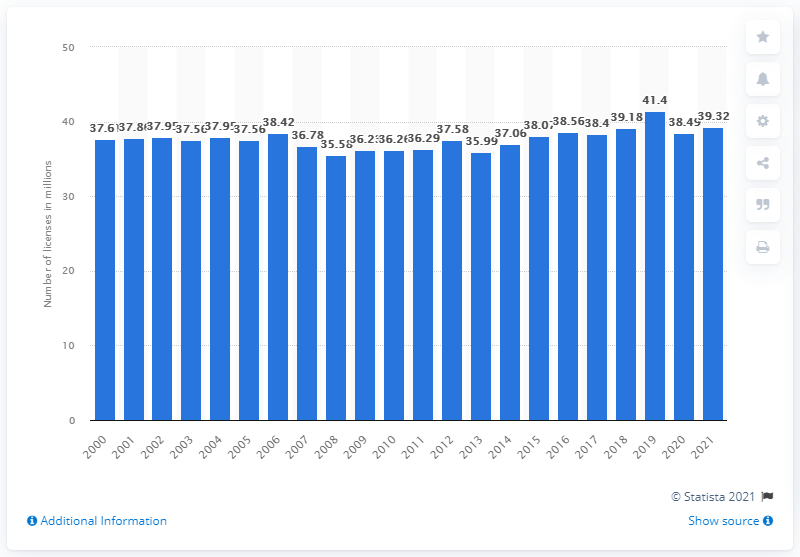Identify some key points in this picture. In the year 2000, there were 38,490 fishing licenses, tags, permits, and stamps in the United States. There were 39.32 fishing licenses, tags, permits, and stamps in the United States in 2021. 